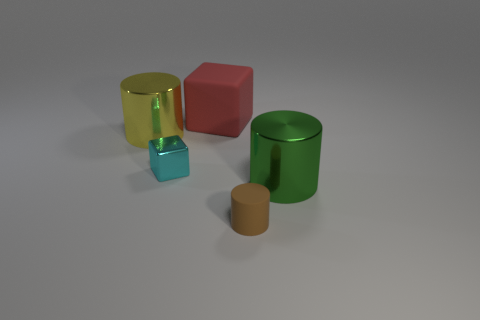Add 3 big green shiny cylinders. How many objects exist? 8 Subtract all cylinders. How many objects are left? 2 Add 3 small cyan shiny blocks. How many small cyan shiny blocks are left? 4 Add 4 brown rubber things. How many brown rubber things exist? 5 Subtract 1 green cylinders. How many objects are left? 4 Subtract all small blue blocks. Subtract all small cyan metallic objects. How many objects are left? 4 